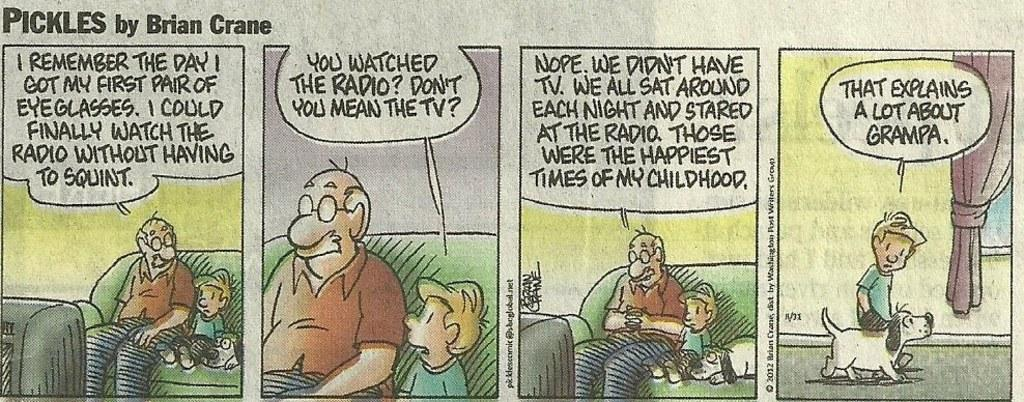What is featured on the poster in the image? There is a poster in the image that features people and dogs. What else can be seen on the poster besides the images? There is text on the poster. What is the purpose of the curtain in the image? The curtain is likely used for decoration or to cover a window or door. What types of objects are visible in the image? There are objects visible in the image, but their specific nature is not mentioned in the provided facts. What is the cause of death depicted on the poster? There is no mention of death or any cause of death in the image or the provided facts. How does the temper of the dogs affect the people on the poster? The provided facts do not mention the temper of the dogs or any interaction between the dogs and the people on the poster. 